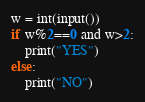<code> <loc_0><loc_0><loc_500><loc_500><_Python_>w = int(input())
if w%2==0 and w>2:
    print("YES")
else:
    print("NO")    </code> 